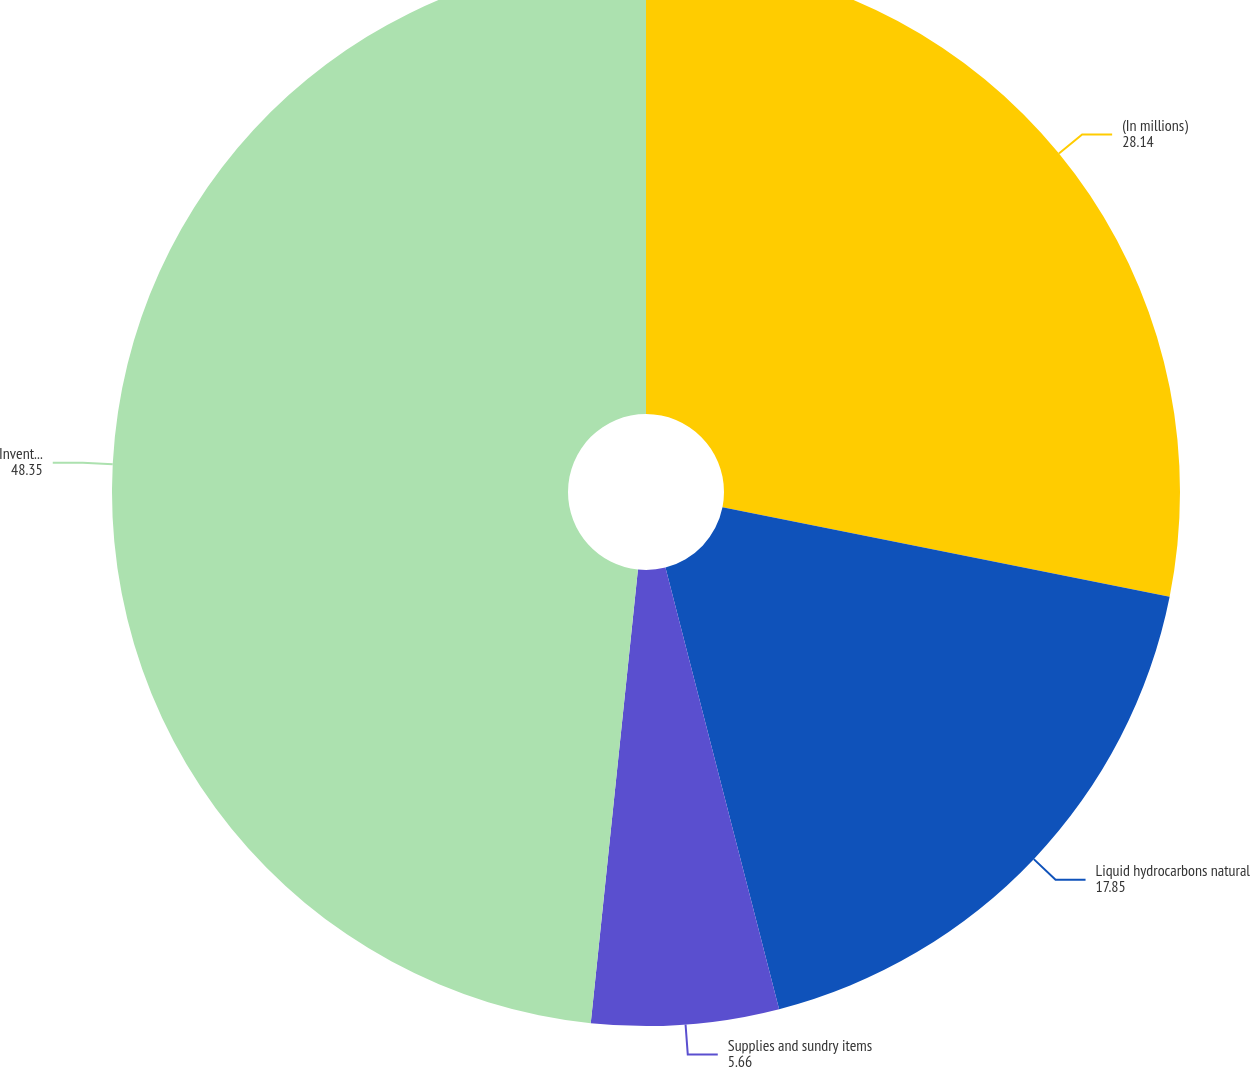<chart> <loc_0><loc_0><loc_500><loc_500><pie_chart><fcel>(In millions)<fcel>Liquid hydrocarbons natural<fcel>Supplies and sundry items<fcel>Inventories at cost<nl><fcel>28.14%<fcel>17.85%<fcel>5.66%<fcel>48.35%<nl></chart> 